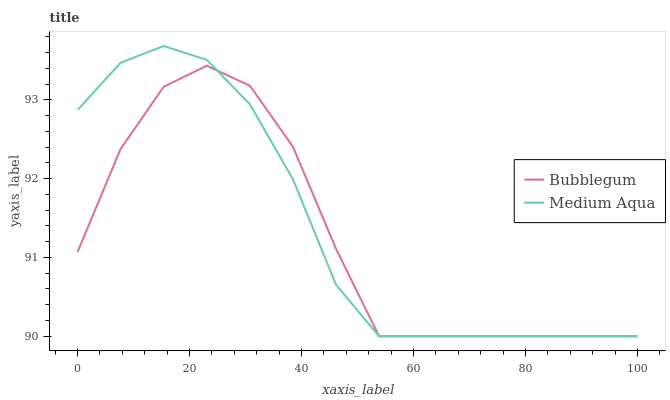Does Bubblegum have the minimum area under the curve?
Answer yes or no. Yes. Does Medium Aqua have the maximum area under the curve?
Answer yes or no. Yes. Does Bubblegum have the maximum area under the curve?
Answer yes or no. No. Is Medium Aqua the smoothest?
Answer yes or no. Yes. Is Bubblegum the roughest?
Answer yes or no. Yes. Is Bubblegum the smoothest?
Answer yes or no. No. Does Medium Aqua have the lowest value?
Answer yes or no. Yes. Does Medium Aqua have the highest value?
Answer yes or no. Yes. Does Bubblegum have the highest value?
Answer yes or no. No. Does Medium Aqua intersect Bubblegum?
Answer yes or no. Yes. Is Medium Aqua less than Bubblegum?
Answer yes or no. No. Is Medium Aqua greater than Bubblegum?
Answer yes or no. No. 